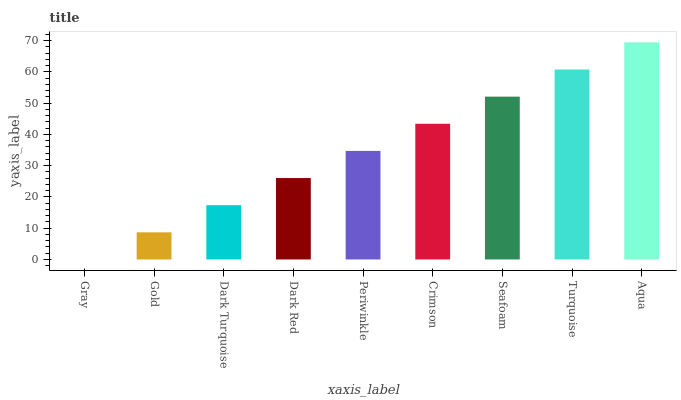Is Gray the minimum?
Answer yes or no. Yes. Is Aqua the maximum?
Answer yes or no. Yes. Is Gold the minimum?
Answer yes or no. No. Is Gold the maximum?
Answer yes or no. No. Is Gold greater than Gray?
Answer yes or no. Yes. Is Gray less than Gold?
Answer yes or no. Yes. Is Gray greater than Gold?
Answer yes or no. No. Is Gold less than Gray?
Answer yes or no. No. Is Periwinkle the high median?
Answer yes or no. Yes. Is Periwinkle the low median?
Answer yes or no. Yes. Is Crimson the high median?
Answer yes or no. No. Is Dark Red the low median?
Answer yes or no. No. 